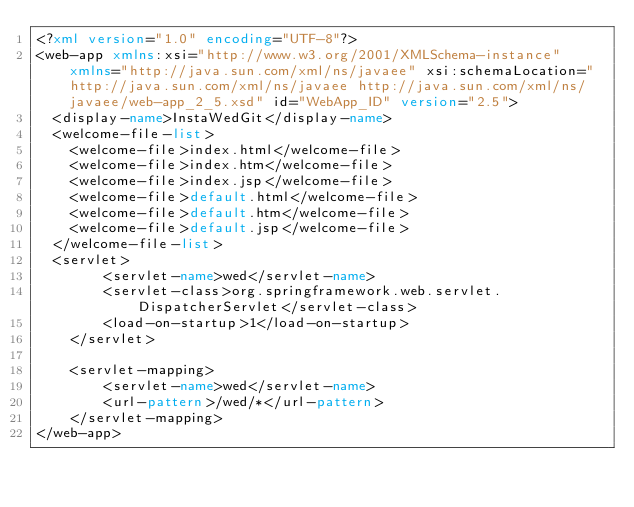Convert code to text. <code><loc_0><loc_0><loc_500><loc_500><_XML_><?xml version="1.0" encoding="UTF-8"?>
<web-app xmlns:xsi="http://www.w3.org/2001/XMLSchema-instance" xmlns="http://java.sun.com/xml/ns/javaee" xsi:schemaLocation="http://java.sun.com/xml/ns/javaee http://java.sun.com/xml/ns/javaee/web-app_2_5.xsd" id="WebApp_ID" version="2.5">
  <display-name>InstaWedGit</display-name>
  <welcome-file-list>
    <welcome-file>index.html</welcome-file>
    <welcome-file>index.htm</welcome-file>
    <welcome-file>index.jsp</welcome-file>
    <welcome-file>default.html</welcome-file>
    <welcome-file>default.htm</welcome-file>
    <welcome-file>default.jsp</welcome-file>
  </welcome-file-list>
  <servlet>
        <servlet-name>wed</servlet-name>
        <servlet-class>org.springframework.web.servlet.DispatcherServlet</servlet-class>
        <load-on-startup>1</load-on-startup>
    </servlet>

    <servlet-mapping>
        <servlet-name>wed</servlet-name>
        <url-pattern>/wed/*</url-pattern>
    </servlet-mapping>
</web-app></code> 